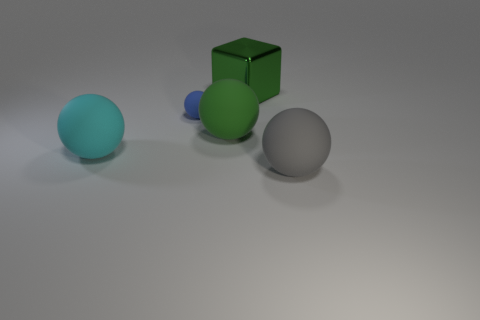The object that is behind the green rubber thing and on the right side of the small matte object is made of what material?
Give a very brief answer. Metal. Are there any other things that have the same shape as the big green metal thing?
Offer a very short reply. No. How many big spheres are both on the right side of the large cyan object and on the left side of the gray rubber thing?
Offer a very short reply. 1. What is the material of the gray ball?
Your answer should be compact. Rubber. Are there the same number of big cyan rubber spheres behind the large green rubber ball and purple metal objects?
Ensure brevity in your answer.  Yes. What number of other tiny blue rubber objects have the same shape as the tiny blue rubber object?
Make the answer very short. 0. Does the big cyan matte thing have the same shape as the green matte thing?
Give a very brief answer. Yes. How many objects are either rubber objects that are on the left side of the large block or green shiny things?
Provide a succinct answer. 4. What is the shape of the big thing behind the big rubber ball that is behind the big matte ball left of the tiny blue object?
Provide a succinct answer. Cube. The blue matte ball has what size?
Provide a short and direct response. Small. 